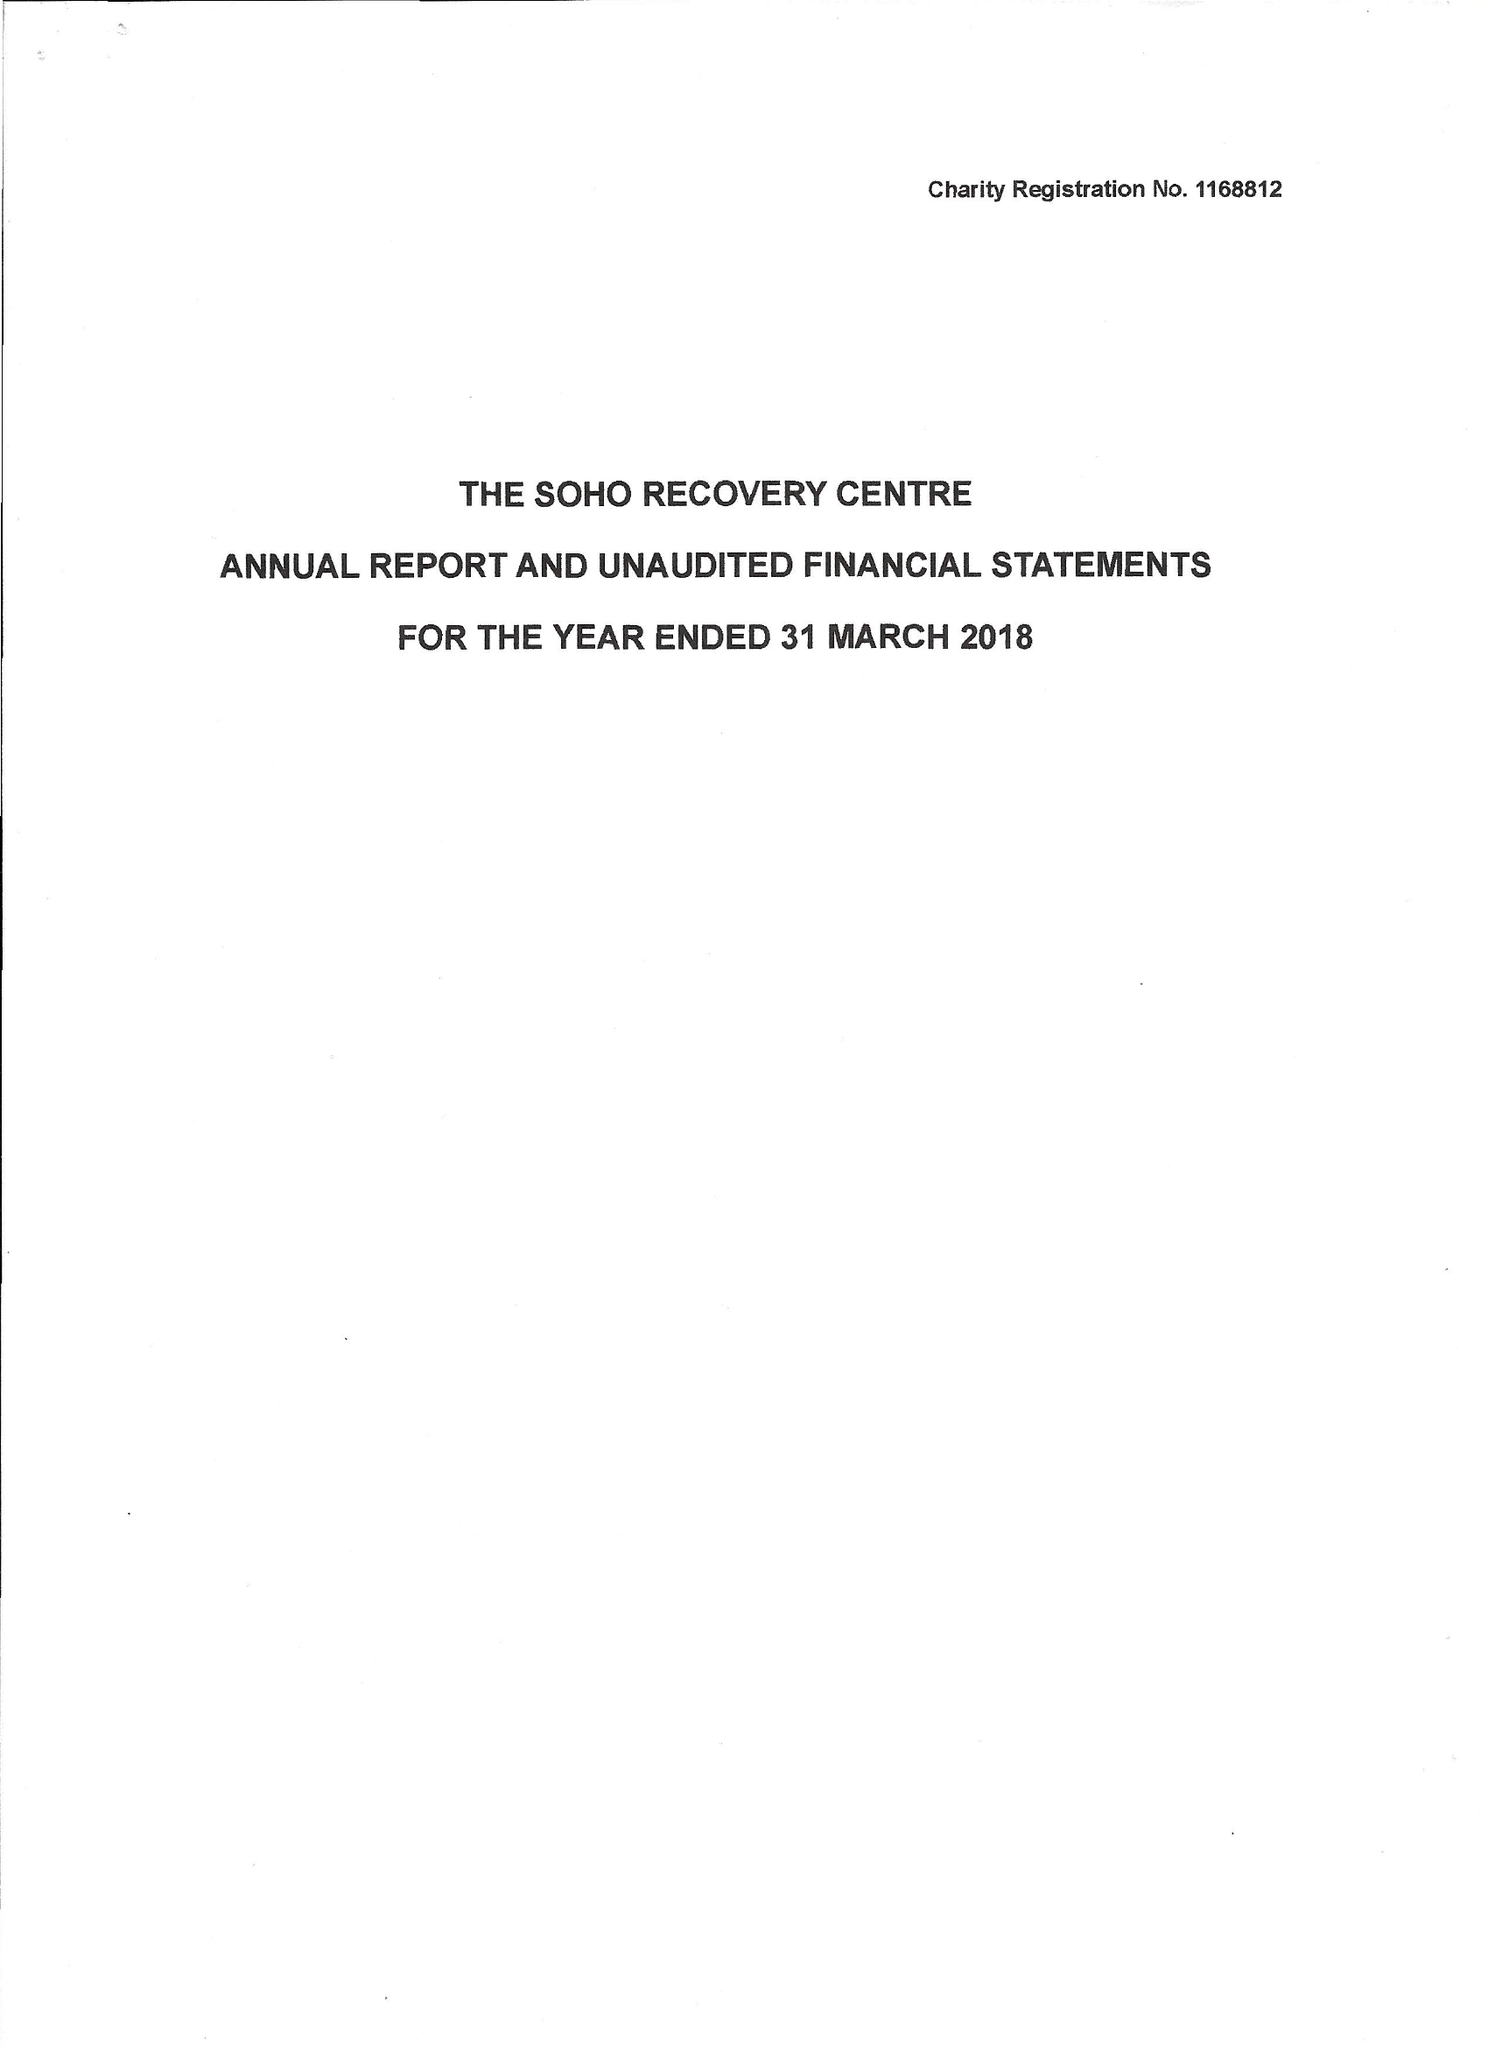What is the value for the address__post_town?
Answer the question using a single word or phrase. LONDON 